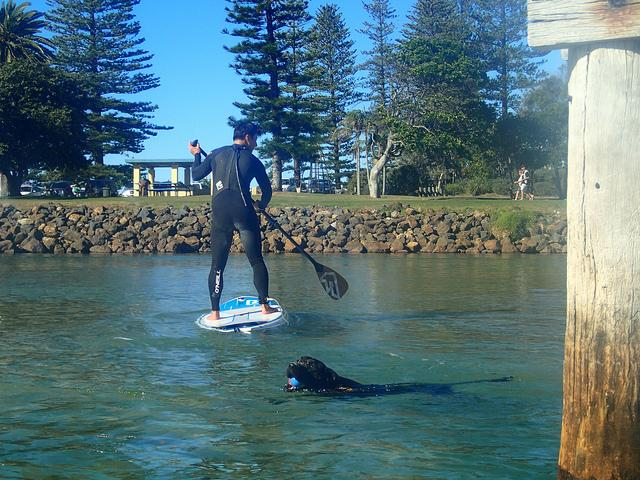What will the dog do with the ball? fetch 